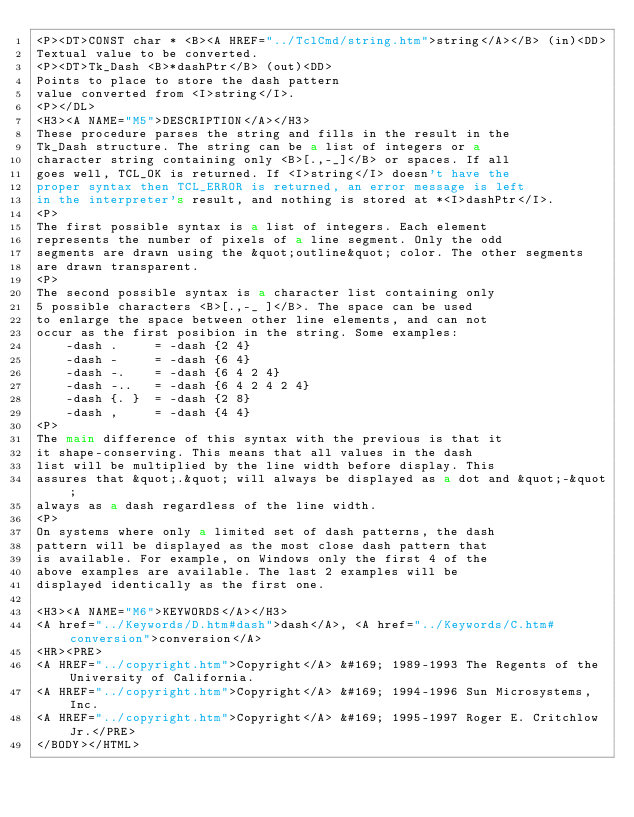Convert code to text. <code><loc_0><loc_0><loc_500><loc_500><_HTML_><P><DT>CONST char * <B><A HREF="../TclCmd/string.htm">string</A></B> (in)<DD>
Textual value to be converted.
<P><DT>Tk_Dash <B>*dashPtr</B> (out)<DD>
Points to place to store the dash pattern
value converted from <I>string</I>.
<P></DL>
<H3><A NAME="M5">DESCRIPTION</A></H3>
These procedure parses the string and fills in the result in the
Tk_Dash structure. The string can be a list of integers or a
character string containing only <B>[.,-_]</B> or spaces. If all
goes well, TCL_OK is returned. If <I>string</I> doesn't have the
proper syntax then TCL_ERROR is returned, an error message is left
in the interpreter's result, and nothing is stored at *<I>dashPtr</I>.
<P>
The first possible syntax is a list of integers. Each element
represents the number of pixels of a line segment. Only the odd
segments are drawn using the &quot;outline&quot; color. The other segments
are drawn transparent.
<P>
The second possible syntax is a character list containing only
5 possible characters <B>[.,-_ ]</B>. The space can be used
to enlarge the space between other line elements, and can not
occur as the first posibion in the string. Some examples:
    -dash .     = -dash {2 4}
    -dash -     = -dash {6 4}
    -dash -.    = -dash {6 4 2 4}
    -dash -..   = -dash {6 4 2 4 2 4}
    -dash {. }  = -dash {2 8}
    -dash ,     = -dash {4 4}
<P>
The main difference of this syntax with the previous is that it
it shape-conserving. This means that all values in the dash
list will be multiplied by the line width before display. This
assures that &quot;.&quot; will always be displayed as a dot and &quot;-&quot;
always as a dash regardless of the line width.
<P>
On systems where only a limited set of dash patterns, the dash
pattern will be displayed as the most close dash pattern that
is available. For example, on Windows only the first 4 of the
above examples are available. The last 2 examples will be
displayed identically as the first one.

<H3><A NAME="M6">KEYWORDS</A></H3>
<A href="../Keywords/D.htm#dash">dash</A>, <A href="../Keywords/C.htm#conversion">conversion</A>
<HR><PRE>
<A HREF="../copyright.htm">Copyright</A> &#169; 1989-1993 The Regents of the University of California.
<A HREF="../copyright.htm">Copyright</A> &#169; 1994-1996 Sun Microsystems, Inc.
<A HREF="../copyright.htm">Copyright</A> &#169; 1995-1997 Roger E. Critchlow Jr.</PRE>
</BODY></HTML>
</code> 